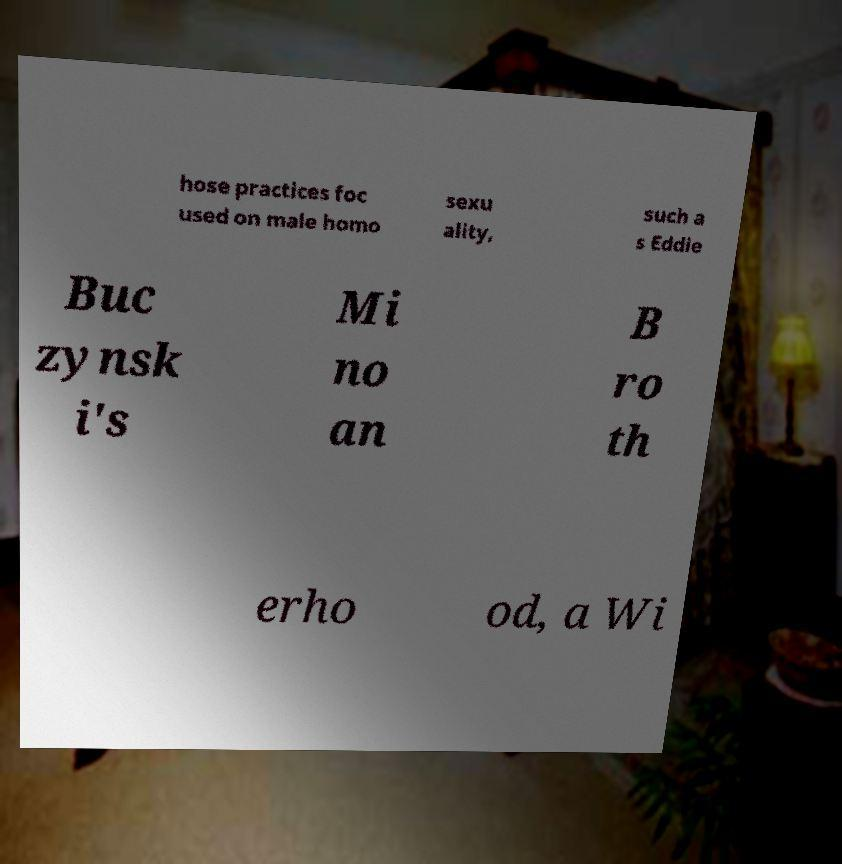I need the written content from this picture converted into text. Can you do that? hose practices foc used on male homo sexu ality, such a s Eddie Buc zynsk i's Mi no an B ro th erho od, a Wi 